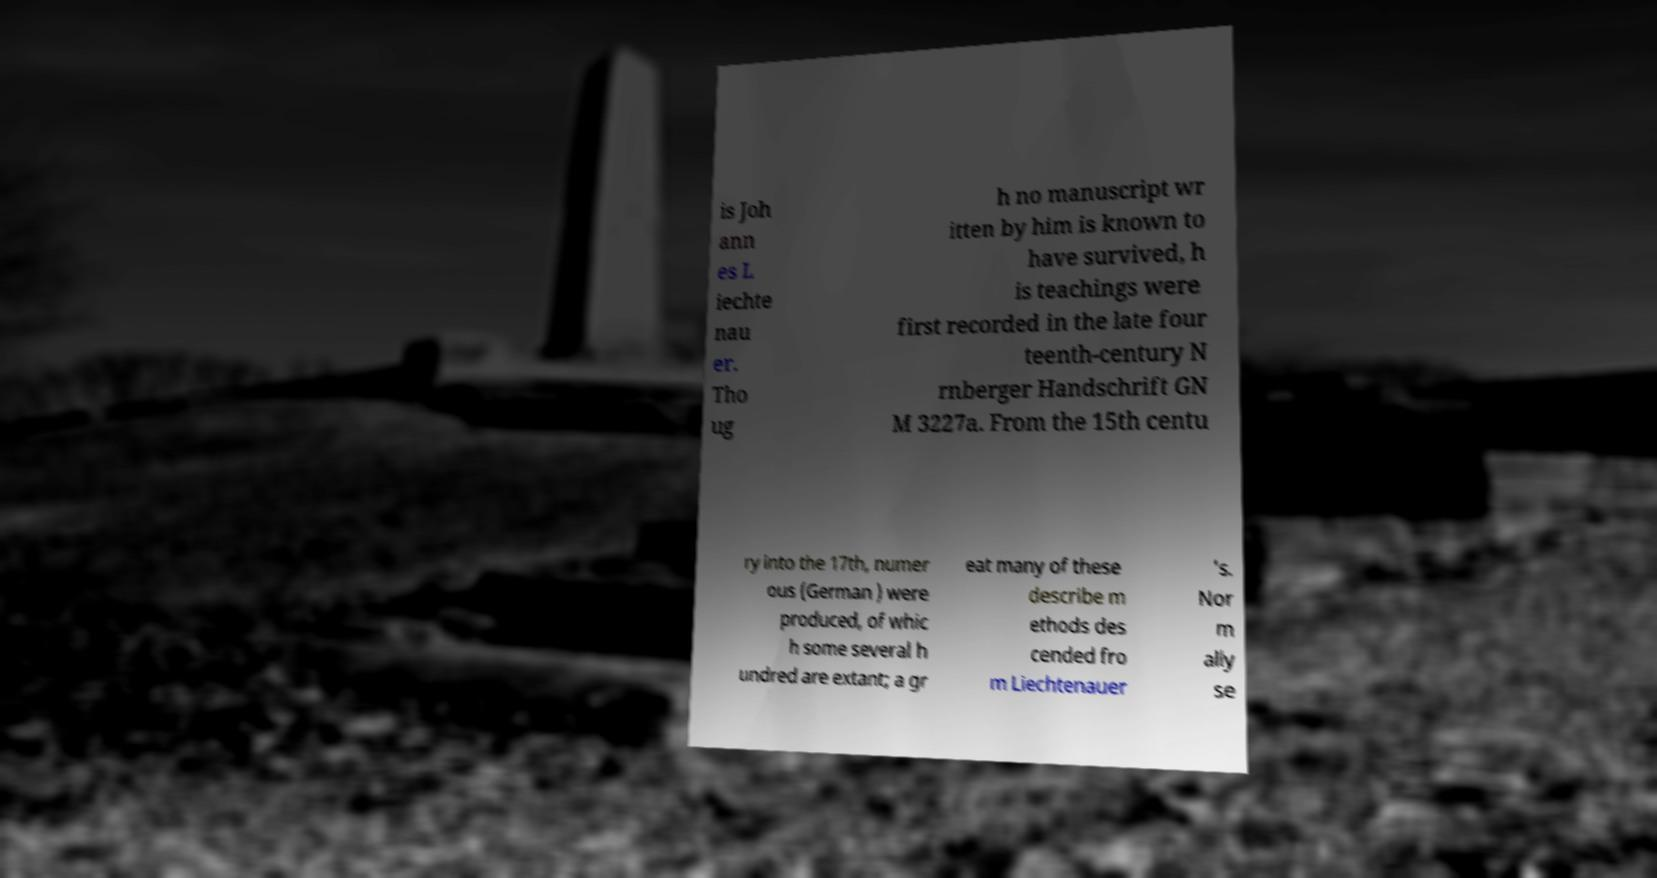Could you assist in decoding the text presented in this image and type it out clearly? is Joh ann es L iechte nau er. Tho ug h no manuscript wr itten by him is known to have survived, h is teachings were first recorded in the late four teenth-century N rnberger Handschrift GN M 3227a. From the 15th centu ry into the 17th, numer ous (German ) were produced, of whic h some several h undred are extant; a gr eat many of these describe m ethods des cended fro m Liechtenauer 's. Nor m ally se 